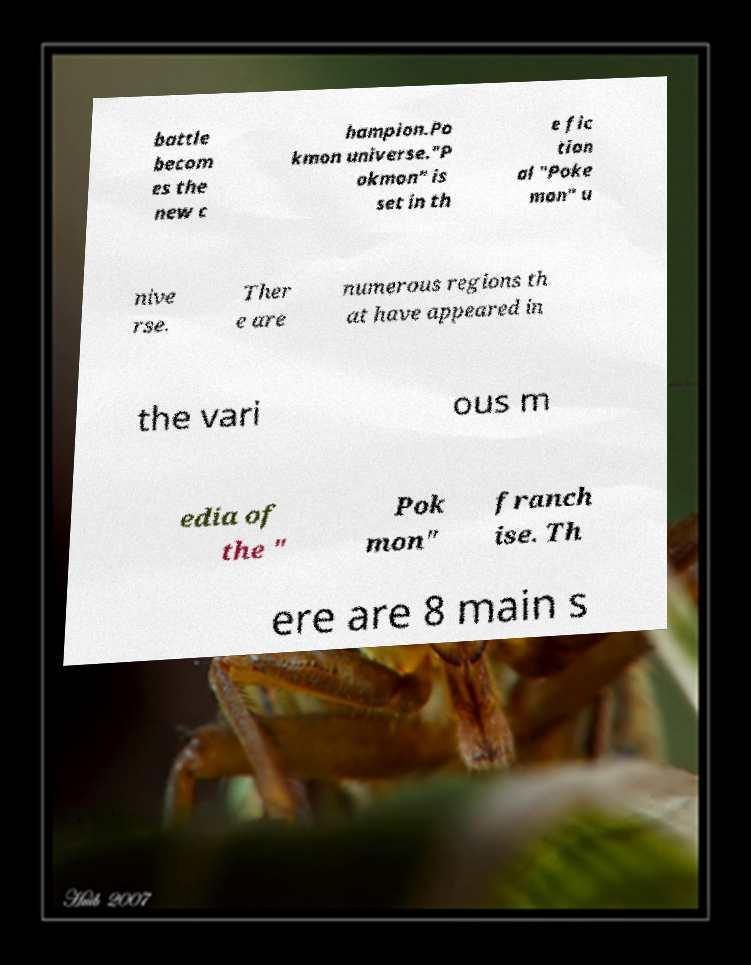Can you accurately transcribe the text from the provided image for me? battle becom es the new c hampion.Po kmon universe."P okmon" is set in th e fic tion al "Poke mon" u nive rse. Ther e are numerous regions th at have appeared in the vari ous m edia of the " Pok mon" franch ise. Th ere are 8 main s 